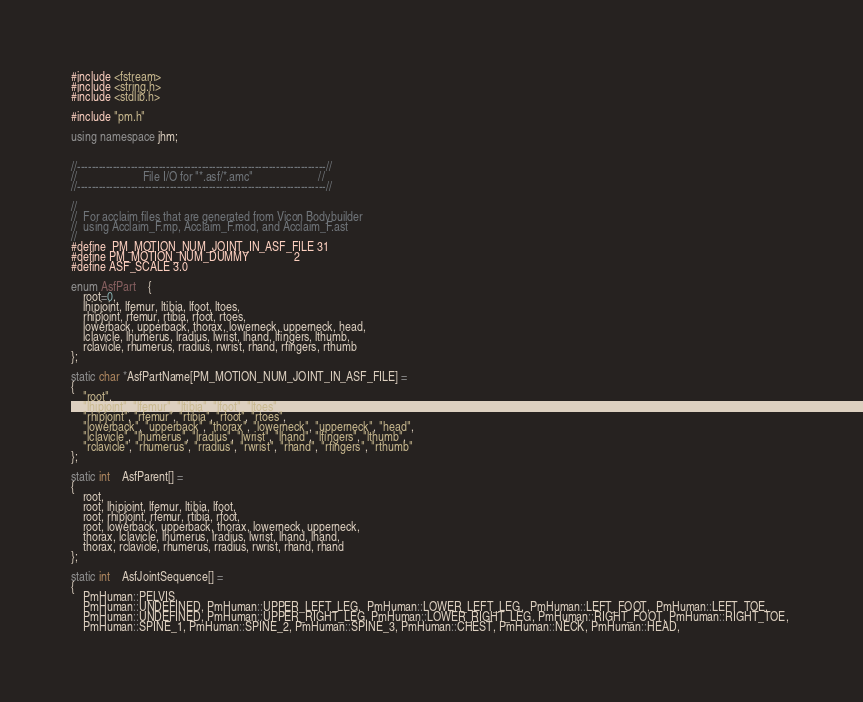Convert code to text. <code><loc_0><loc_0><loc_500><loc_500><_C++_>
#include <fstream>
#include <string.h>
#include <stdlib.h>

#include "pm.h"

using namespace jhm;


//----------------------------------------------------------------------//
//						File I/O for "*.asf/*.amc"						//
//----------------------------------------------------------------------//

//
//  For acclaim files that are generated from Vicon Bodybuilder
//  using Acclaim_F.mp, Acclaim_F.mod, and Acclaim_F.ast
//
#define	PM_MOTION_NUM_JOINT_IN_ASF_FILE	31
#define PM_MOTION_NUM_DUMMY				 2
#define ASF_SCALE 3.0

enum AsfPart	{
	root=0,
	lhipjoint, lfemur, ltibia, lfoot, ltoes,
	rhipjoint, rfemur, rtibia, rfoot, rtoes,
	lowerback, upperback, thorax, lowerneck, upperneck, head,
	lclavicle, lhumerus, lradius, lwrist, lhand, lfingers, lthumb,
	rclavicle, rhumerus, rradius, rwrist, rhand, rfingers, rthumb
};

static char *AsfPartName[PM_MOTION_NUM_JOINT_IN_ASF_FILE] =
{
	"root",
	"lhipjoint", "lfemur", "ltibia", "lfoot", "ltoes",
	"rhipjoint", "rfemur", "rtibia", "rfoot", "rtoes",
	"lowerback", "upperback", "thorax", "lowerneck", "upperneck", "head",
	"lclavicle", "lhumerus", "lradius", "lwrist", "lhand", "lfingers", "lthumb",
	"rclavicle", "rhumerus", "rradius", "rwrist", "rhand", "rfingers", "rthumb"
};

static int	AsfParent[] =
{
	root,
	root, lhipjoint, lfemur, ltibia, lfoot,
	root, rhipjoint, rfemur, rtibia, rfoot,
	root, lowerback, upperback, thorax, lowerneck, upperneck,
	thorax, lclavicle, lhumerus, lradius, lwrist, lhand, lhand,
	thorax, rclavicle, rhumerus, rradius, rwrist, rhand, rhand
};

static int	AsfJointSequence[] =
{
	PmHuman::PELVIS,
	PmHuman::UNDEFINED, PmHuman::UPPER_LEFT_LEG,  PmHuman::LOWER_LEFT_LEG,  PmHuman::LEFT_FOOT,  PmHuman::LEFT_TOE,  
	PmHuman::UNDEFINED, PmHuman::UPPER_RIGHT_LEG, PmHuman::LOWER_RIGHT_LEG, PmHuman::RIGHT_FOOT, PmHuman::RIGHT_TOE, 
	PmHuman::SPINE_1, PmHuman::SPINE_2, PmHuman::SPINE_3, PmHuman::CHEST, PmHuman::NECK, PmHuman::HEAD,</code> 